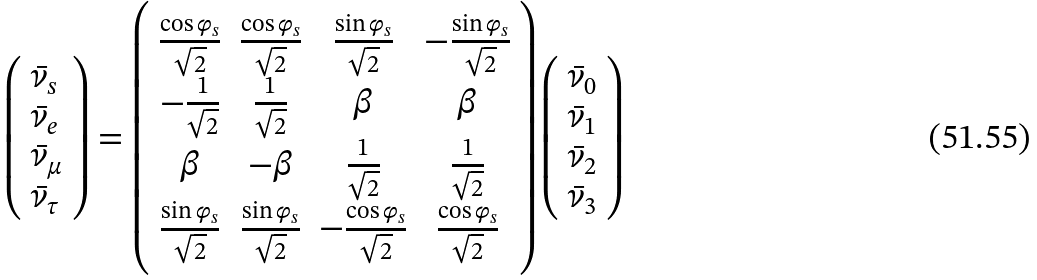<formula> <loc_0><loc_0><loc_500><loc_500>\left ( \begin{array} { l } \bar { \nu } _ { s } \\ \bar { \nu } _ { e } \\ \bar { \nu } _ { \mu } \\ \bar { \nu } _ { \tau } \\ \end{array} \right ) = \left ( \begin{array} { c c c c } \frac { \cos \varphi _ { s } } { \sqrt { 2 } } & \frac { \cos \varphi _ { s } } { \sqrt { 2 } } & \frac { \sin \varphi _ { s } } { \sqrt { 2 } } & - \frac { \sin \varphi _ { s } } { \sqrt { 2 } } \\ - \frac { 1 } { \sqrt { 2 } } & \frac { 1 } { \sqrt { 2 } } & \beta & \beta \\ \beta & - \beta & \frac { 1 } { \sqrt { 2 } } & \frac { 1 } { \sqrt { 2 } } \\ \frac { \sin \varphi _ { s } } { \sqrt { 2 } } & \frac { \sin \varphi _ { s } } { \sqrt { 2 } } & - \frac { \cos \varphi _ { s } } { \sqrt { 2 } } & \frac { \cos \varphi _ { s } } { \sqrt { 2 } } \\ \end{array} \right ) \left ( \begin{array} { l } \bar { \nu } _ { 0 } \\ \bar { \nu } _ { 1 } \\ \bar { \nu } _ { 2 } \\ \bar { \nu } _ { 3 } \\ \end{array} \right )</formula> 